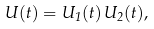Convert formula to latex. <formula><loc_0><loc_0><loc_500><loc_500>U ( t ) = U _ { 1 } ( t ) \, U _ { 2 } ( t ) ,</formula> 